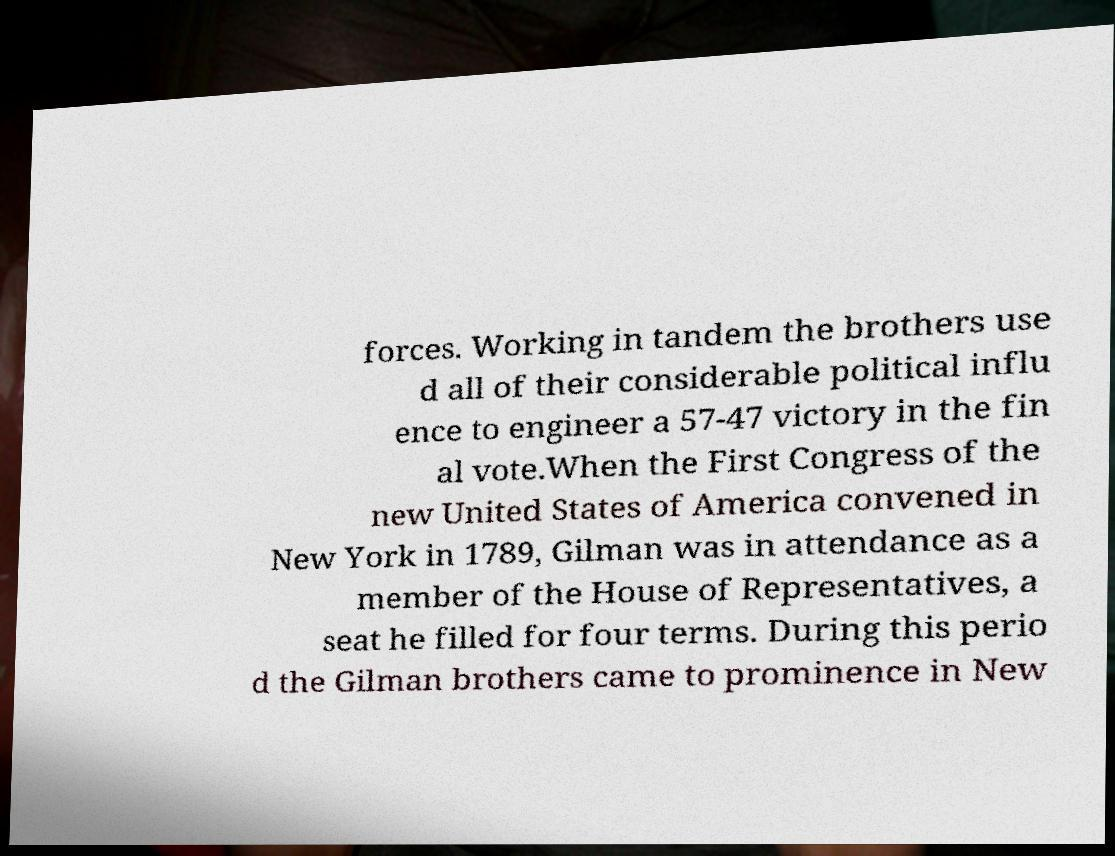Could you assist in decoding the text presented in this image and type it out clearly? forces. Working in tandem the brothers use d all of their considerable political influ ence to engineer a 57-47 victory in the fin al vote.When the First Congress of the new United States of America convened in New York in 1789, Gilman was in attendance as a member of the House of Representatives, a seat he filled for four terms. During this perio d the Gilman brothers came to prominence in New 